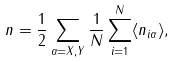Convert formula to latex. <formula><loc_0><loc_0><loc_500><loc_500>n = \frac { 1 } { 2 } \sum _ { \alpha = X , Y } \frac { 1 } { N } \sum _ { i = 1 } ^ { N } \langle n _ { i \alpha } \rangle ,</formula> 